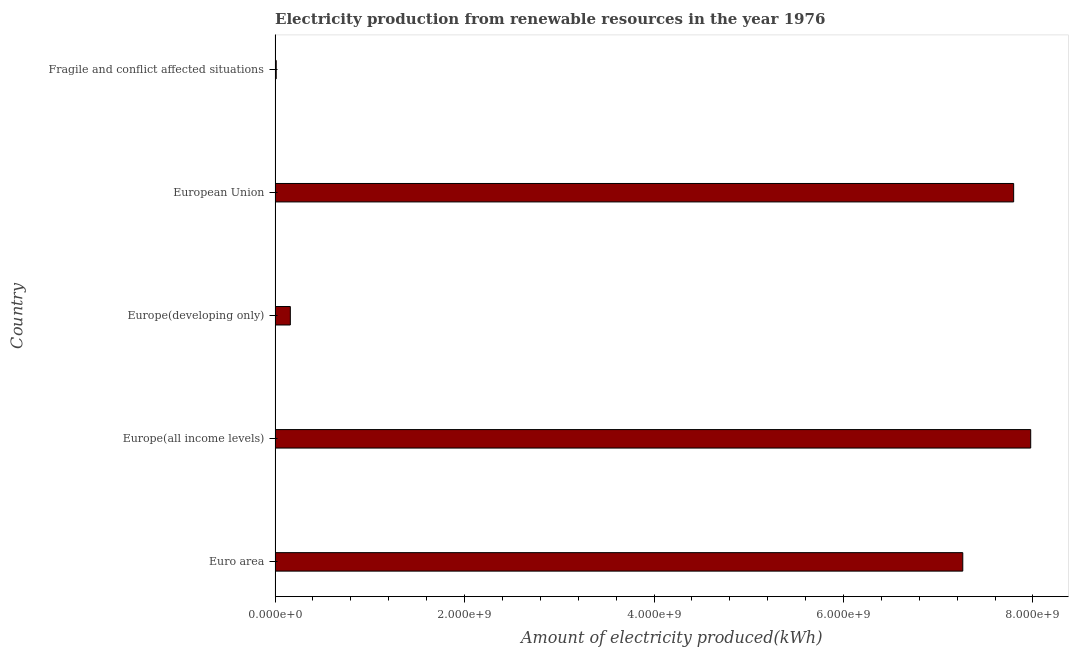Does the graph contain grids?
Provide a succinct answer. No. What is the title of the graph?
Offer a terse response. Electricity production from renewable resources in the year 1976. What is the label or title of the X-axis?
Your answer should be very brief. Amount of electricity produced(kWh). What is the amount of electricity produced in Euro area?
Your answer should be compact. 7.26e+09. Across all countries, what is the maximum amount of electricity produced?
Your answer should be compact. 7.98e+09. In which country was the amount of electricity produced maximum?
Your answer should be compact. Europe(all income levels). In which country was the amount of electricity produced minimum?
Your answer should be very brief. Fragile and conflict affected situations. What is the sum of the amount of electricity produced?
Offer a terse response. 2.32e+1. What is the difference between the amount of electricity produced in Europe(all income levels) and Europe(developing only)?
Ensure brevity in your answer.  7.82e+09. What is the average amount of electricity produced per country?
Offer a very short reply. 4.64e+09. What is the median amount of electricity produced?
Your answer should be very brief. 7.26e+09. What is the ratio of the amount of electricity produced in Europe(all income levels) to that in European Union?
Make the answer very short. 1.02. What is the difference between the highest and the second highest amount of electricity produced?
Offer a very short reply. 1.80e+08. Is the sum of the amount of electricity produced in Euro area and Europe(developing only) greater than the maximum amount of electricity produced across all countries?
Give a very brief answer. No. What is the difference between the highest and the lowest amount of electricity produced?
Ensure brevity in your answer.  7.96e+09. In how many countries, is the amount of electricity produced greater than the average amount of electricity produced taken over all countries?
Offer a very short reply. 3. How many bars are there?
Provide a succinct answer. 5. Are all the bars in the graph horizontal?
Provide a succinct answer. Yes. What is the difference between two consecutive major ticks on the X-axis?
Offer a very short reply. 2.00e+09. What is the Amount of electricity produced(kWh) in Euro area?
Provide a succinct answer. 7.26e+09. What is the Amount of electricity produced(kWh) in Europe(all income levels)?
Your answer should be very brief. 7.98e+09. What is the Amount of electricity produced(kWh) in Europe(developing only)?
Ensure brevity in your answer.  1.61e+08. What is the Amount of electricity produced(kWh) of European Union?
Keep it short and to the point. 7.80e+09. What is the difference between the Amount of electricity produced(kWh) in Euro area and Europe(all income levels)?
Give a very brief answer. -7.17e+08. What is the difference between the Amount of electricity produced(kWh) in Euro area and Europe(developing only)?
Give a very brief answer. 7.10e+09. What is the difference between the Amount of electricity produced(kWh) in Euro area and European Union?
Give a very brief answer. -5.37e+08. What is the difference between the Amount of electricity produced(kWh) in Euro area and Fragile and conflict affected situations?
Offer a very short reply. 7.25e+09. What is the difference between the Amount of electricity produced(kWh) in Europe(all income levels) and Europe(developing only)?
Give a very brief answer. 7.82e+09. What is the difference between the Amount of electricity produced(kWh) in Europe(all income levels) and European Union?
Offer a very short reply. 1.80e+08. What is the difference between the Amount of electricity produced(kWh) in Europe(all income levels) and Fragile and conflict affected situations?
Provide a short and direct response. 7.96e+09. What is the difference between the Amount of electricity produced(kWh) in Europe(developing only) and European Union?
Offer a very short reply. -7.64e+09. What is the difference between the Amount of electricity produced(kWh) in Europe(developing only) and Fragile and conflict affected situations?
Give a very brief answer. 1.49e+08. What is the difference between the Amount of electricity produced(kWh) in European Union and Fragile and conflict affected situations?
Give a very brief answer. 7.78e+09. What is the ratio of the Amount of electricity produced(kWh) in Euro area to that in Europe(all income levels)?
Give a very brief answer. 0.91. What is the ratio of the Amount of electricity produced(kWh) in Euro area to that in Europe(developing only)?
Offer a very short reply. 45.09. What is the ratio of the Amount of electricity produced(kWh) in Euro area to that in European Union?
Give a very brief answer. 0.93. What is the ratio of the Amount of electricity produced(kWh) in Euro area to that in Fragile and conflict affected situations?
Your answer should be compact. 604.92. What is the ratio of the Amount of electricity produced(kWh) in Europe(all income levels) to that in Europe(developing only)?
Give a very brief answer. 49.54. What is the ratio of the Amount of electricity produced(kWh) in Europe(all income levels) to that in European Union?
Your answer should be very brief. 1.02. What is the ratio of the Amount of electricity produced(kWh) in Europe(all income levels) to that in Fragile and conflict affected situations?
Ensure brevity in your answer.  664.67. What is the ratio of the Amount of electricity produced(kWh) in Europe(developing only) to that in European Union?
Offer a terse response. 0.02. What is the ratio of the Amount of electricity produced(kWh) in Europe(developing only) to that in Fragile and conflict affected situations?
Keep it short and to the point. 13.42. What is the ratio of the Amount of electricity produced(kWh) in European Union to that in Fragile and conflict affected situations?
Provide a short and direct response. 649.67. 